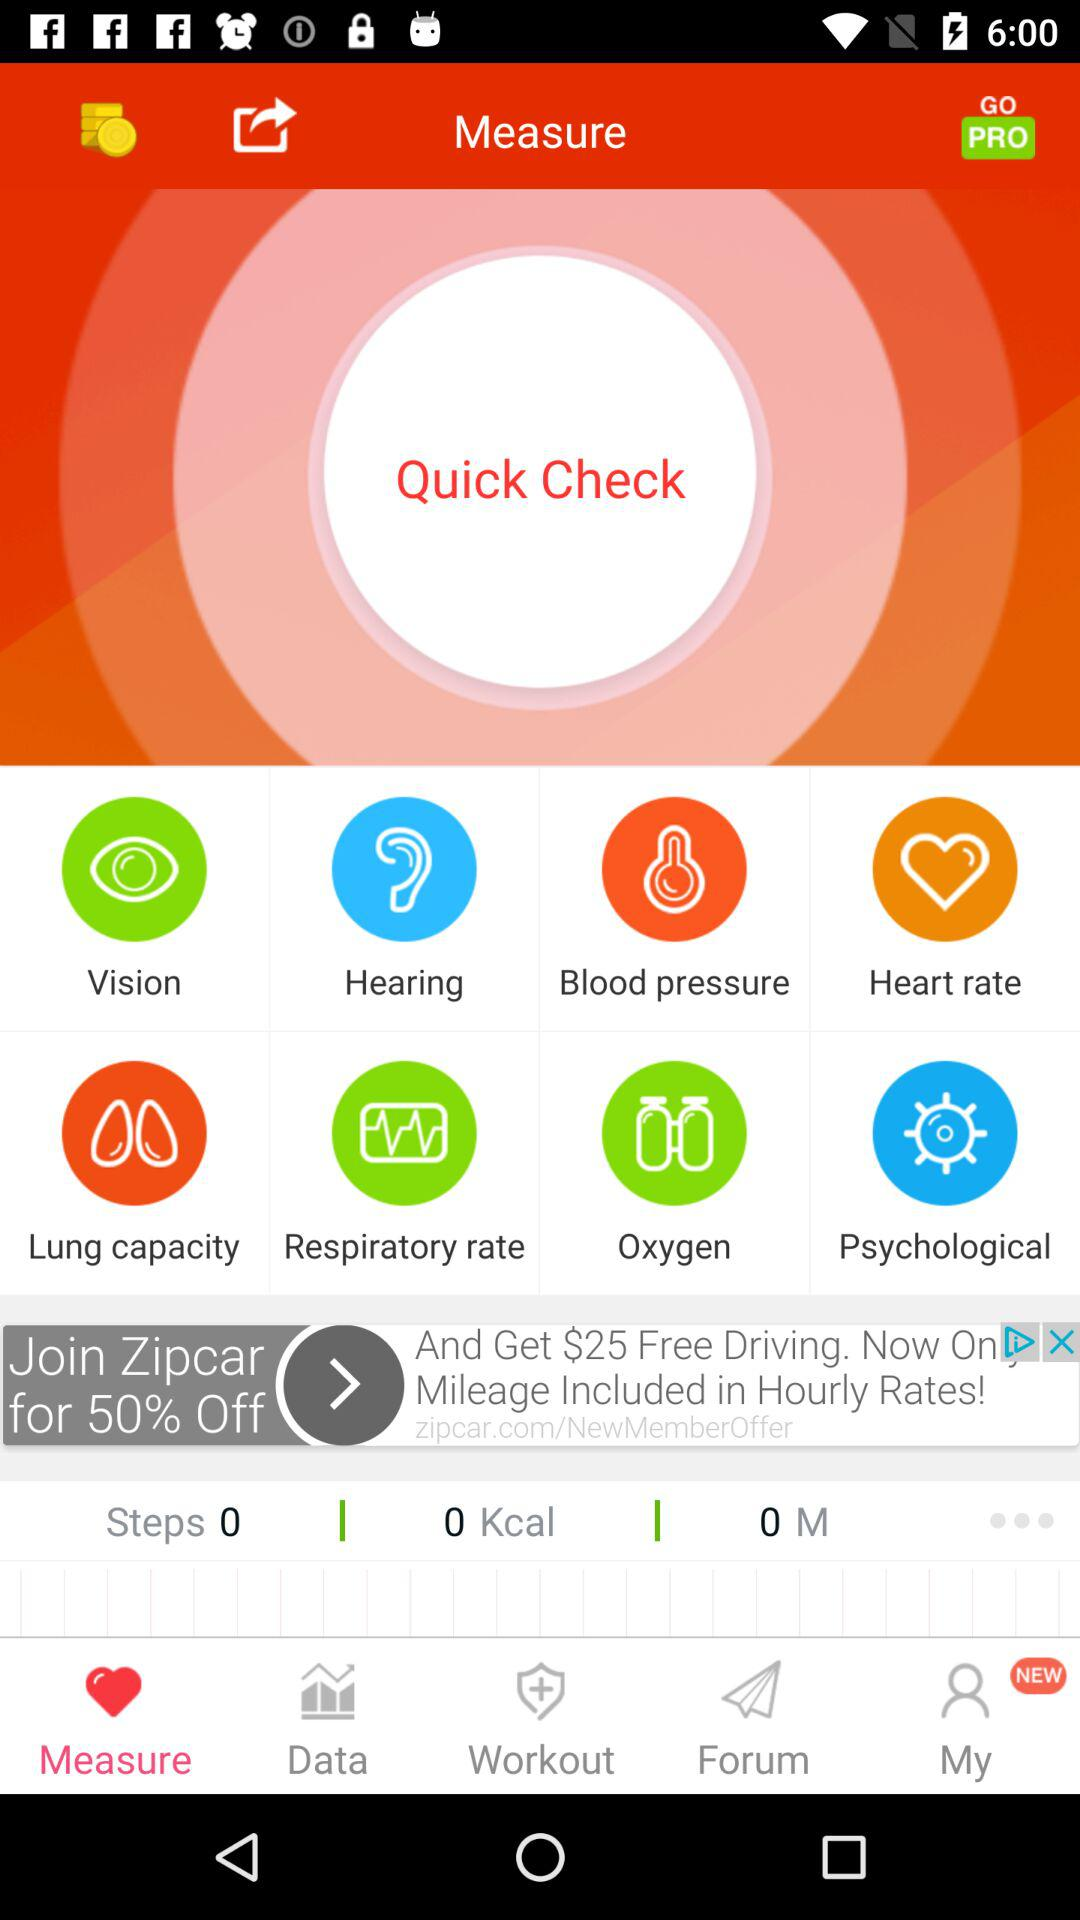Which tab is selected? The selected tab is "Measure". 